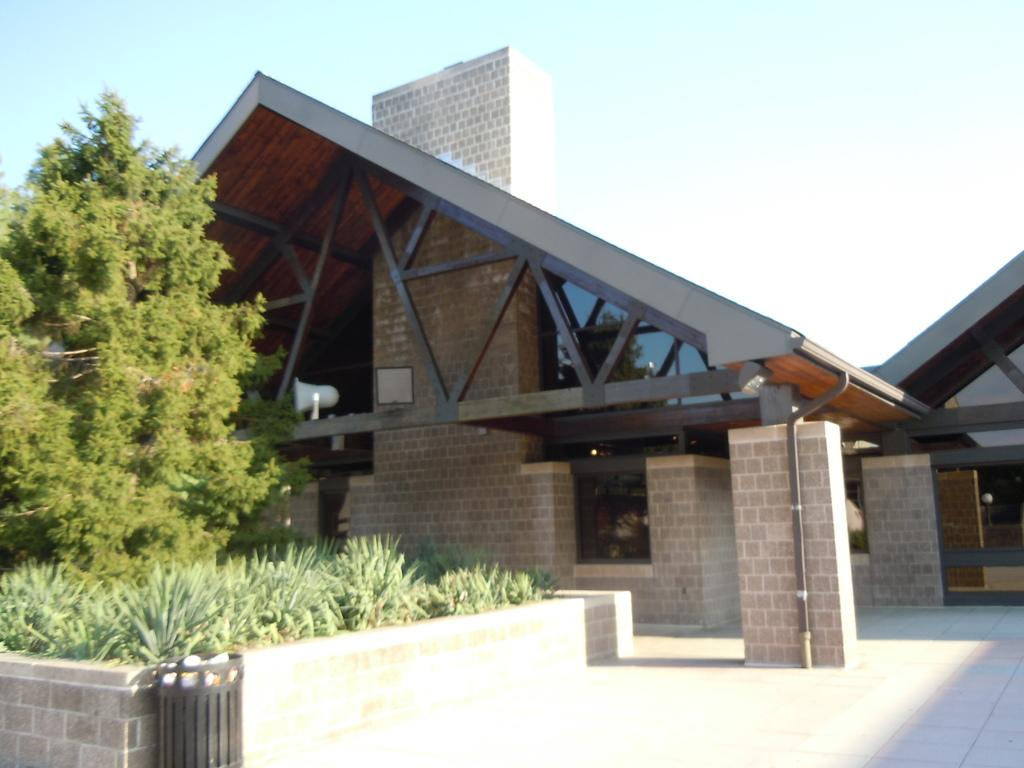What type of vegetation is in the front of the image? There are plants in the front of the image. What structure can be seen in the background of the image? There is a building in the background of the image. Where is the tree located in the image? The tree is on the left side of the image. What is the condition of the sky in the image? The sky is cloudy in the image. What type of bucket is being used in the discussion in the image? There is no discussion or bucket present in the image. How does the light affect the plants in the image? There is no mention of light in the image, so we cannot determine its effect on the plants. 